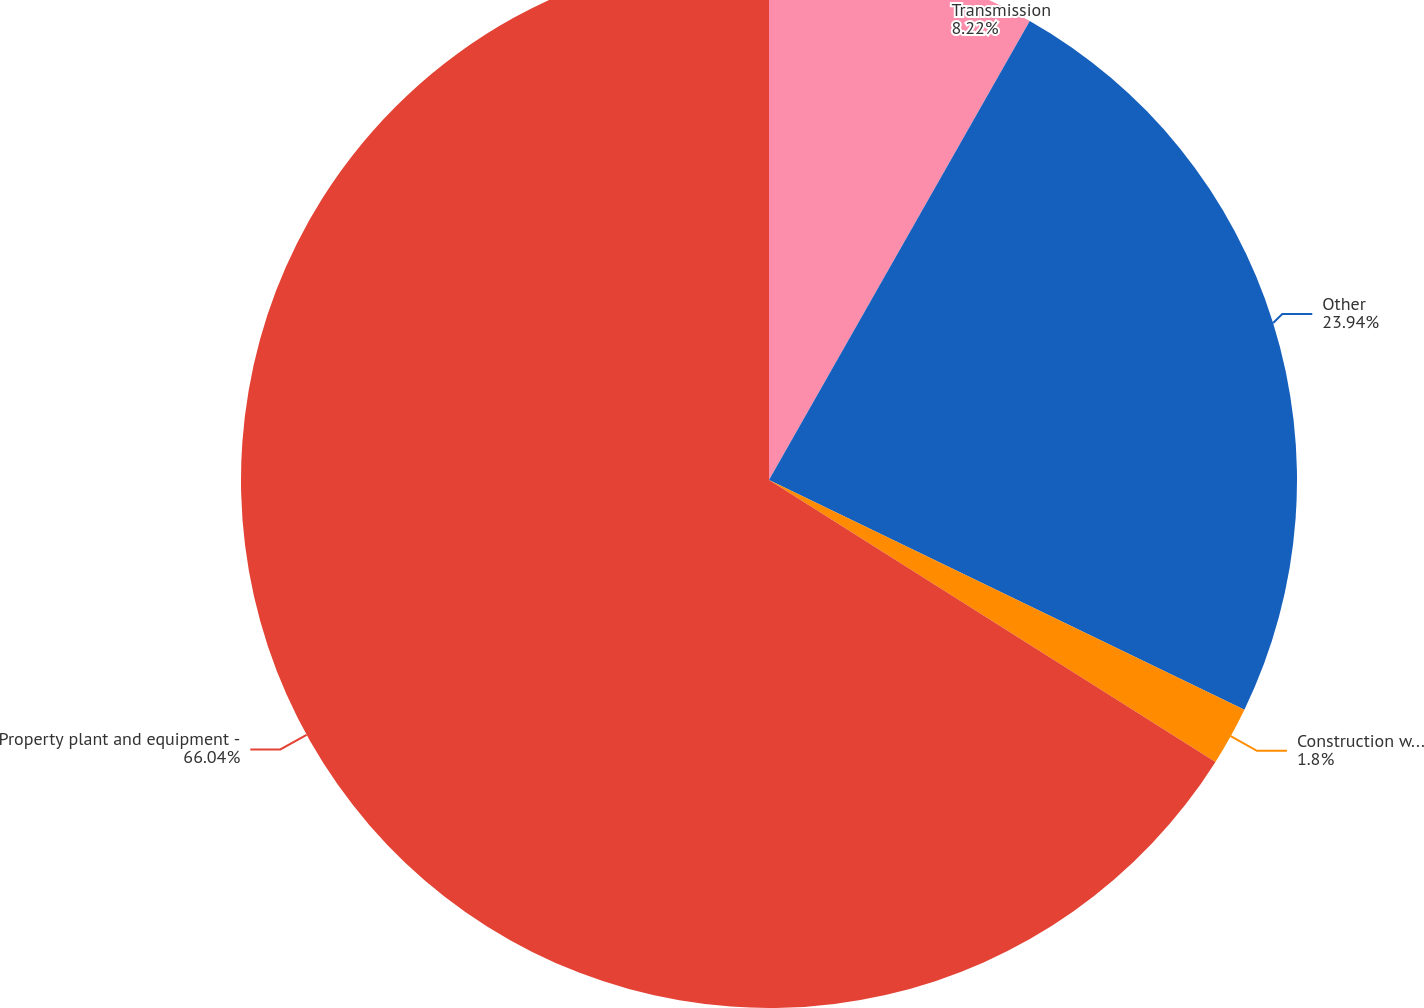<chart> <loc_0><loc_0><loc_500><loc_500><pie_chart><fcel>Transmission<fcel>Other<fcel>Construction work in progress<fcel>Property plant and equipment -<nl><fcel>8.22%<fcel>23.94%<fcel>1.8%<fcel>66.03%<nl></chart> 